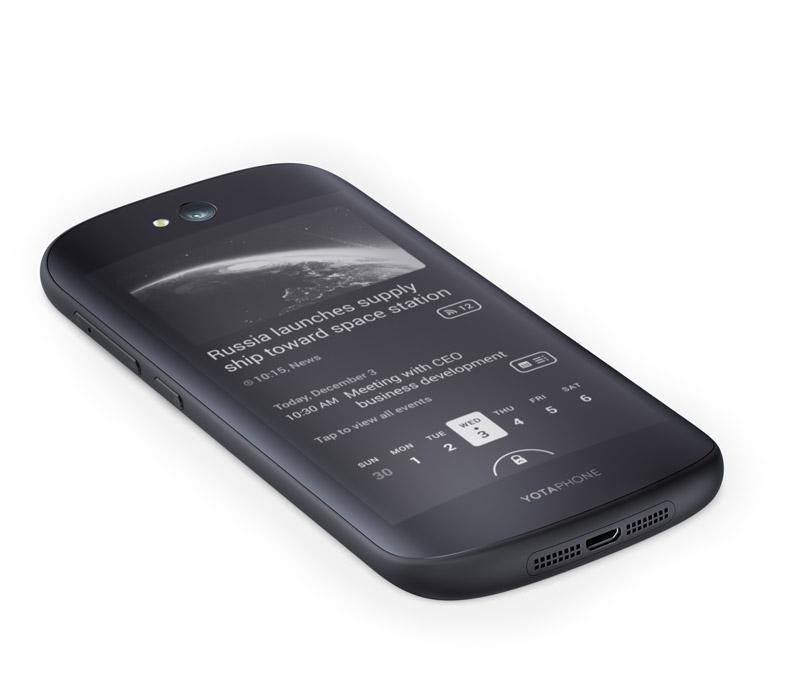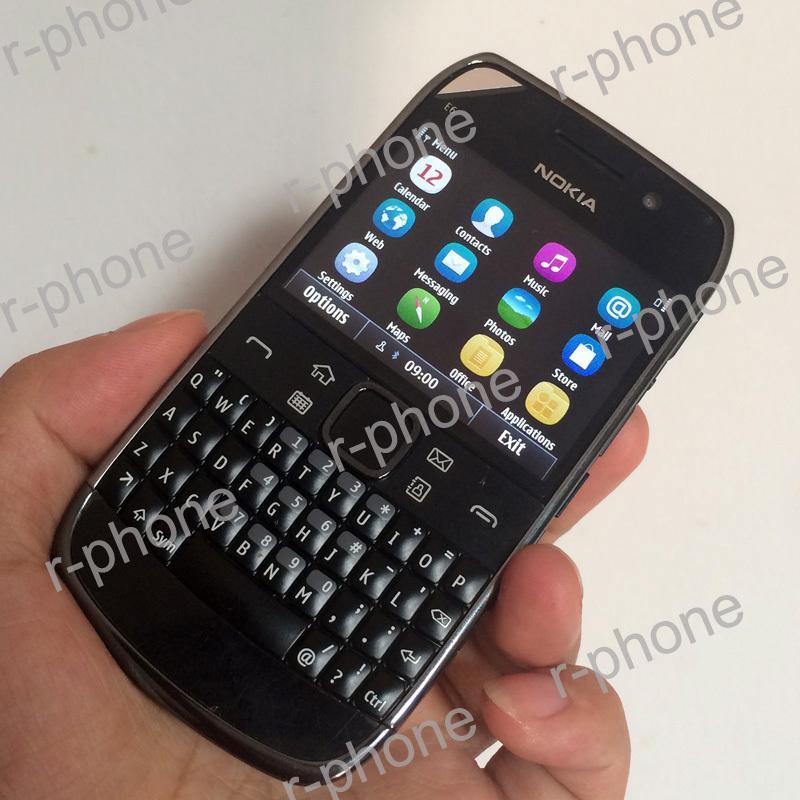The first image is the image on the left, the second image is the image on the right. Considering the images on both sides, is "One of the phones has physical keys for typing." valid? Answer yes or no. Yes. The first image is the image on the left, the second image is the image on the right. Evaluate the accuracy of this statement regarding the images: "The back of a phone is visible.". Is it true? Answer yes or no. No. 